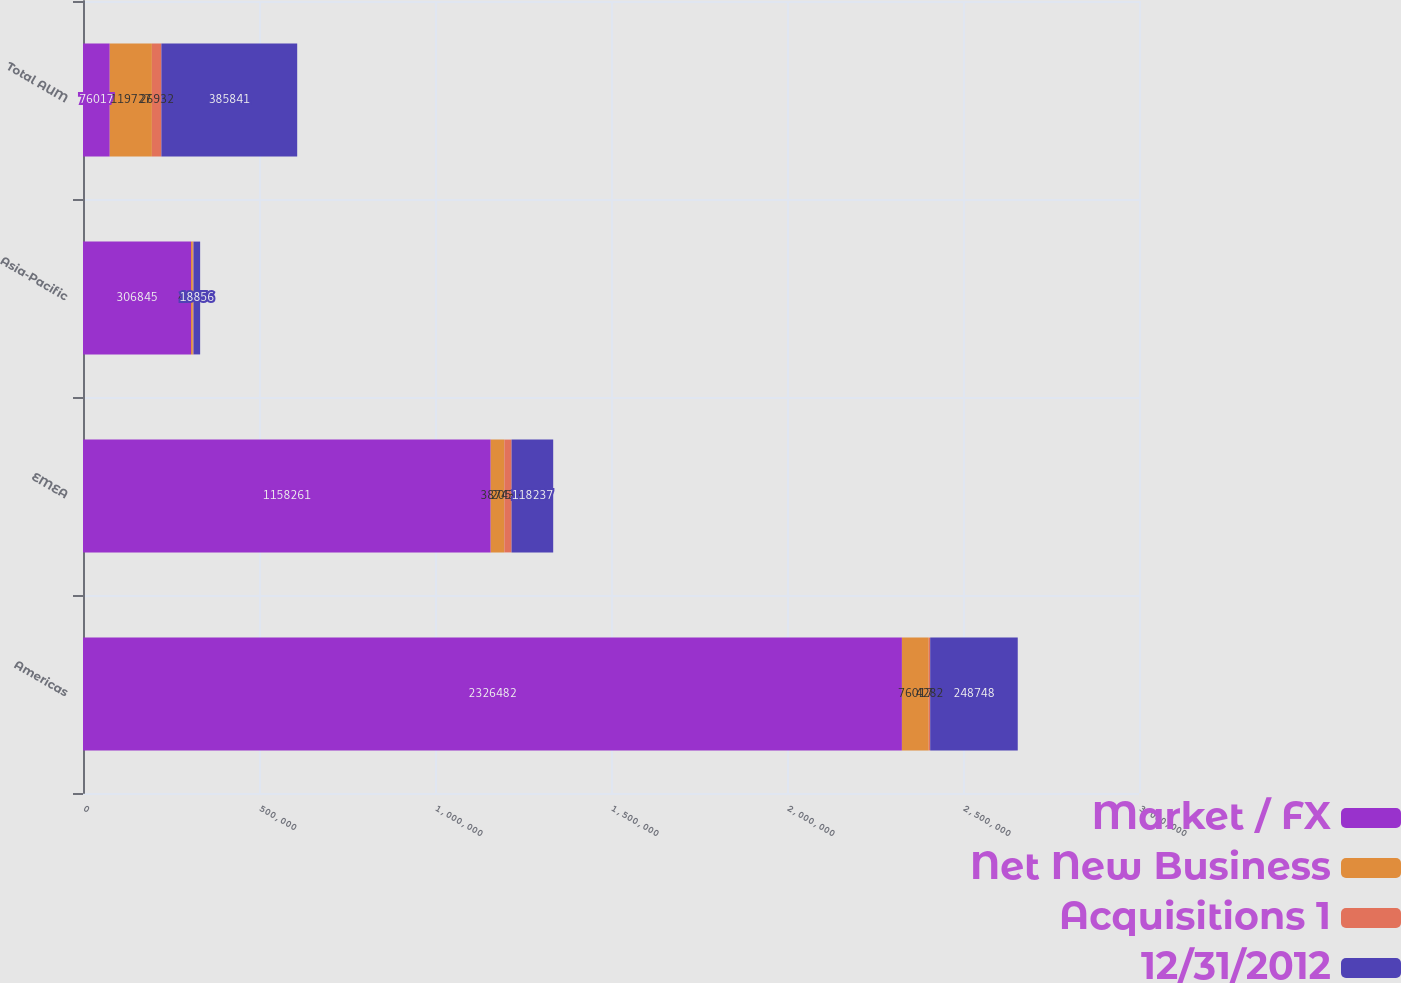<chart> <loc_0><loc_0><loc_500><loc_500><stacked_bar_chart><ecel><fcel>Americas<fcel>EMEA<fcel>Asia-Pacific<fcel>Total AUM<nl><fcel>Market / FX<fcel>2.32648e+06<fcel>1.15826e+06<fcel>306845<fcel>76017<nl><fcel>Net New Business<fcel>76017<fcel>38743<fcel>4967<fcel>119727<nl><fcel>Acquisitions 1<fcel>4282<fcel>20536<fcel>2114<fcel>26932<nl><fcel>12/31/2012<fcel>248748<fcel>118237<fcel>18856<fcel>385841<nl></chart> 